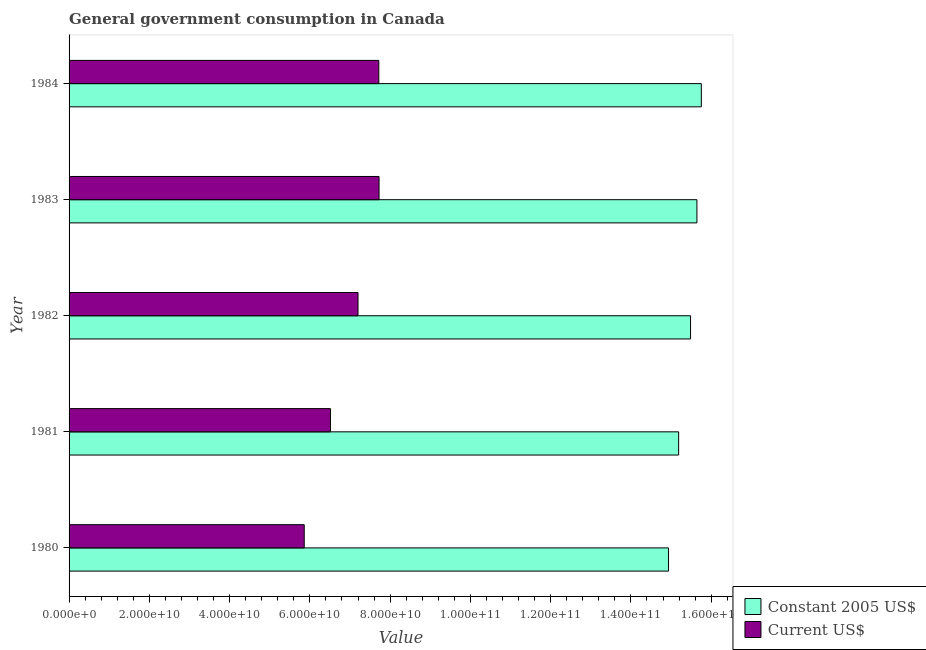How many different coloured bars are there?
Provide a succinct answer. 2. How many groups of bars are there?
Offer a very short reply. 5. Are the number of bars per tick equal to the number of legend labels?
Offer a terse response. Yes. What is the label of the 4th group of bars from the top?
Your answer should be very brief. 1981. What is the value consumed in constant 2005 us$ in 1981?
Offer a very short reply. 1.52e+11. Across all years, what is the maximum value consumed in current us$?
Make the answer very short. 7.72e+1. Across all years, what is the minimum value consumed in current us$?
Provide a short and direct response. 5.86e+1. What is the total value consumed in current us$ in the graph?
Offer a terse response. 3.50e+11. What is the difference between the value consumed in current us$ in 1980 and that in 1984?
Offer a very short reply. -1.86e+1. What is the difference between the value consumed in current us$ in 1984 and the value consumed in constant 2005 us$ in 1983?
Ensure brevity in your answer.  -7.93e+1. What is the average value consumed in current us$ per year?
Offer a terse response. 7.00e+1. In the year 1983, what is the difference between the value consumed in current us$ and value consumed in constant 2005 us$?
Keep it short and to the point. -7.92e+1. In how many years, is the value consumed in constant 2005 us$ greater than 88000000000 ?
Give a very brief answer. 5. What is the ratio of the value consumed in current us$ in 1981 to that in 1982?
Keep it short and to the point. 0.91. Is the value consumed in current us$ in 1982 less than that in 1983?
Keep it short and to the point. Yes. What is the difference between the highest and the second highest value consumed in constant 2005 us$?
Provide a short and direct response. 1.10e+09. What is the difference between the highest and the lowest value consumed in current us$?
Offer a terse response. 1.86e+1. Is the sum of the value consumed in current us$ in 1982 and 1984 greater than the maximum value consumed in constant 2005 us$ across all years?
Your answer should be compact. No. What does the 1st bar from the top in 1984 represents?
Make the answer very short. Current US$. What does the 2nd bar from the bottom in 1982 represents?
Give a very brief answer. Current US$. Are all the bars in the graph horizontal?
Offer a very short reply. Yes. What is the difference between two consecutive major ticks on the X-axis?
Ensure brevity in your answer.  2.00e+1. What is the title of the graph?
Give a very brief answer. General government consumption in Canada. What is the label or title of the X-axis?
Your answer should be compact. Value. What is the label or title of the Y-axis?
Ensure brevity in your answer.  Year. What is the Value in Constant 2005 US$ in 1980?
Your answer should be very brief. 1.49e+11. What is the Value of Current US$ in 1980?
Your answer should be compact. 5.86e+1. What is the Value of Constant 2005 US$ in 1981?
Offer a terse response. 1.52e+11. What is the Value of Current US$ in 1981?
Ensure brevity in your answer.  6.51e+1. What is the Value in Constant 2005 US$ in 1982?
Your response must be concise. 1.55e+11. What is the Value of Current US$ in 1982?
Your answer should be compact. 7.20e+1. What is the Value of Constant 2005 US$ in 1983?
Ensure brevity in your answer.  1.56e+11. What is the Value in Current US$ in 1983?
Make the answer very short. 7.72e+1. What is the Value in Constant 2005 US$ in 1984?
Provide a short and direct response. 1.58e+11. What is the Value of Current US$ in 1984?
Your response must be concise. 7.72e+1. Across all years, what is the maximum Value in Constant 2005 US$?
Ensure brevity in your answer.  1.58e+11. Across all years, what is the maximum Value in Current US$?
Your answer should be very brief. 7.72e+1. Across all years, what is the minimum Value in Constant 2005 US$?
Your answer should be compact. 1.49e+11. Across all years, what is the minimum Value of Current US$?
Provide a succinct answer. 5.86e+1. What is the total Value of Constant 2005 US$ in the graph?
Provide a short and direct response. 7.70e+11. What is the total Value of Current US$ in the graph?
Offer a terse response. 3.50e+11. What is the difference between the Value of Constant 2005 US$ in 1980 and that in 1981?
Offer a very short reply. -2.52e+09. What is the difference between the Value of Current US$ in 1980 and that in 1981?
Provide a short and direct response. -6.53e+09. What is the difference between the Value of Constant 2005 US$ in 1980 and that in 1982?
Offer a terse response. -5.49e+09. What is the difference between the Value in Current US$ in 1980 and that in 1982?
Your answer should be compact. -1.34e+1. What is the difference between the Value of Constant 2005 US$ in 1980 and that in 1983?
Make the answer very short. -7.07e+09. What is the difference between the Value of Current US$ in 1980 and that in 1983?
Provide a short and direct response. -1.86e+1. What is the difference between the Value in Constant 2005 US$ in 1980 and that in 1984?
Make the answer very short. -8.17e+09. What is the difference between the Value of Current US$ in 1980 and that in 1984?
Offer a very short reply. -1.86e+1. What is the difference between the Value of Constant 2005 US$ in 1981 and that in 1982?
Ensure brevity in your answer.  -2.97e+09. What is the difference between the Value of Current US$ in 1981 and that in 1982?
Your answer should be compact. -6.87e+09. What is the difference between the Value in Constant 2005 US$ in 1981 and that in 1983?
Offer a terse response. -4.55e+09. What is the difference between the Value in Current US$ in 1981 and that in 1983?
Provide a succinct answer. -1.21e+1. What is the difference between the Value of Constant 2005 US$ in 1981 and that in 1984?
Ensure brevity in your answer.  -5.65e+09. What is the difference between the Value of Current US$ in 1981 and that in 1984?
Provide a succinct answer. -1.21e+1. What is the difference between the Value of Constant 2005 US$ in 1982 and that in 1983?
Your answer should be compact. -1.59e+09. What is the difference between the Value in Current US$ in 1982 and that in 1983?
Your answer should be compact. -5.24e+09. What is the difference between the Value of Constant 2005 US$ in 1982 and that in 1984?
Provide a short and direct response. -2.69e+09. What is the difference between the Value of Current US$ in 1982 and that in 1984?
Provide a short and direct response. -5.18e+09. What is the difference between the Value in Constant 2005 US$ in 1983 and that in 1984?
Offer a very short reply. -1.10e+09. What is the difference between the Value of Current US$ in 1983 and that in 1984?
Ensure brevity in your answer.  6.33e+07. What is the difference between the Value of Constant 2005 US$ in 1980 and the Value of Current US$ in 1981?
Make the answer very short. 8.42e+1. What is the difference between the Value of Constant 2005 US$ in 1980 and the Value of Current US$ in 1982?
Your response must be concise. 7.74e+1. What is the difference between the Value in Constant 2005 US$ in 1980 and the Value in Current US$ in 1983?
Offer a very short reply. 7.21e+1. What is the difference between the Value of Constant 2005 US$ in 1980 and the Value of Current US$ in 1984?
Your answer should be compact. 7.22e+1. What is the difference between the Value of Constant 2005 US$ in 1981 and the Value of Current US$ in 1982?
Provide a succinct answer. 7.99e+1. What is the difference between the Value in Constant 2005 US$ in 1981 and the Value in Current US$ in 1983?
Your response must be concise. 7.47e+1. What is the difference between the Value in Constant 2005 US$ in 1981 and the Value in Current US$ in 1984?
Provide a short and direct response. 7.47e+1. What is the difference between the Value of Constant 2005 US$ in 1982 and the Value of Current US$ in 1983?
Offer a very short reply. 7.76e+1. What is the difference between the Value in Constant 2005 US$ in 1982 and the Value in Current US$ in 1984?
Provide a short and direct response. 7.77e+1. What is the difference between the Value of Constant 2005 US$ in 1983 and the Value of Current US$ in 1984?
Keep it short and to the point. 7.93e+1. What is the average Value of Constant 2005 US$ per year?
Your response must be concise. 1.54e+11. What is the average Value in Current US$ per year?
Your response must be concise. 7.00e+1. In the year 1980, what is the difference between the Value of Constant 2005 US$ and Value of Current US$?
Offer a terse response. 9.08e+1. In the year 1981, what is the difference between the Value of Constant 2005 US$ and Value of Current US$?
Make the answer very short. 8.68e+1. In the year 1982, what is the difference between the Value in Constant 2005 US$ and Value in Current US$?
Keep it short and to the point. 8.29e+1. In the year 1983, what is the difference between the Value in Constant 2005 US$ and Value in Current US$?
Offer a very short reply. 7.92e+1. In the year 1984, what is the difference between the Value in Constant 2005 US$ and Value in Current US$?
Your answer should be very brief. 8.04e+1. What is the ratio of the Value in Constant 2005 US$ in 1980 to that in 1981?
Provide a succinct answer. 0.98. What is the ratio of the Value of Current US$ in 1980 to that in 1981?
Make the answer very short. 0.9. What is the ratio of the Value in Constant 2005 US$ in 1980 to that in 1982?
Offer a terse response. 0.96. What is the ratio of the Value in Current US$ in 1980 to that in 1982?
Provide a short and direct response. 0.81. What is the ratio of the Value of Constant 2005 US$ in 1980 to that in 1983?
Give a very brief answer. 0.95. What is the ratio of the Value in Current US$ in 1980 to that in 1983?
Provide a succinct answer. 0.76. What is the ratio of the Value of Constant 2005 US$ in 1980 to that in 1984?
Your response must be concise. 0.95. What is the ratio of the Value in Current US$ in 1980 to that in 1984?
Your answer should be very brief. 0.76. What is the ratio of the Value in Constant 2005 US$ in 1981 to that in 1982?
Give a very brief answer. 0.98. What is the ratio of the Value of Current US$ in 1981 to that in 1982?
Your response must be concise. 0.9. What is the ratio of the Value in Constant 2005 US$ in 1981 to that in 1983?
Your answer should be very brief. 0.97. What is the ratio of the Value in Current US$ in 1981 to that in 1983?
Offer a very short reply. 0.84. What is the ratio of the Value in Constant 2005 US$ in 1981 to that in 1984?
Provide a succinct answer. 0.96. What is the ratio of the Value of Current US$ in 1981 to that in 1984?
Your answer should be compact. 0.84. What is the ratio of the Value of Constant 2005 US$ in 1982 to that in 1983?
Your answer should be very brief. 0.99. What is the ratio of the Value in Current US$ in 1982 to that in 1983?
Provide a succinct answer. 0.93. What is the ratio of the Value of Constant 2005 US$ in 1982 to that in 1984?
Offer a terse response. 0.98. What is the ratio of the Value in Current US$ in 1982 to that in 1984?
Your response must be concise. 0.93. What is the difference between the highest and the second highest Value in Constant 2005 US$?
Provide a short and direct response. 1.10e+09. What is the difference between the highest and the second highest Value in Current US$?
Your answer should be very brief. 6.33e+07. What is the difference between the highest and the lowest Value of Constant 2005 US$?
Keep it short and to the point. 8.17e+09. What is the difference between the highest and the lowest Value of Current US$?
Keep it short and to the point. 1.86e+1. 